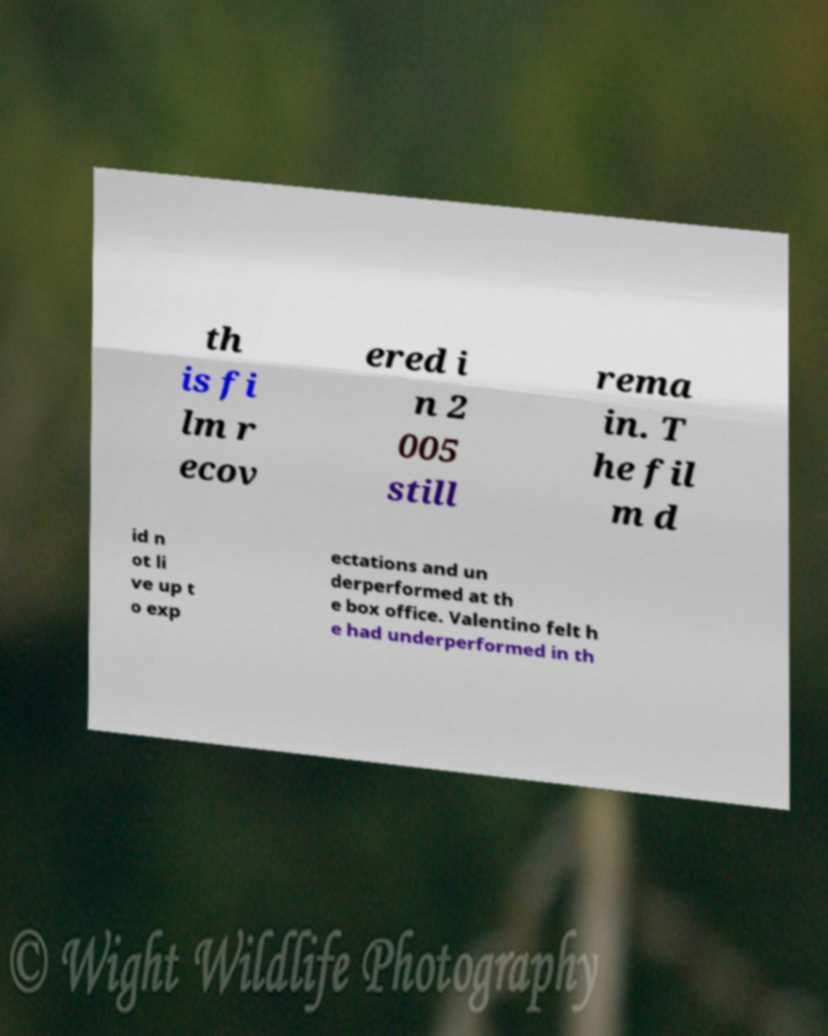For documentation purposes, I need the text within this image transcribed. Could you provide that? th is fi lm r ecov ered i n 2 005 still rema in. T he fil m d id n ot li ve up t o exp ectations and un derperformed at th e box office. Valentino felt h e had underperformed in th 